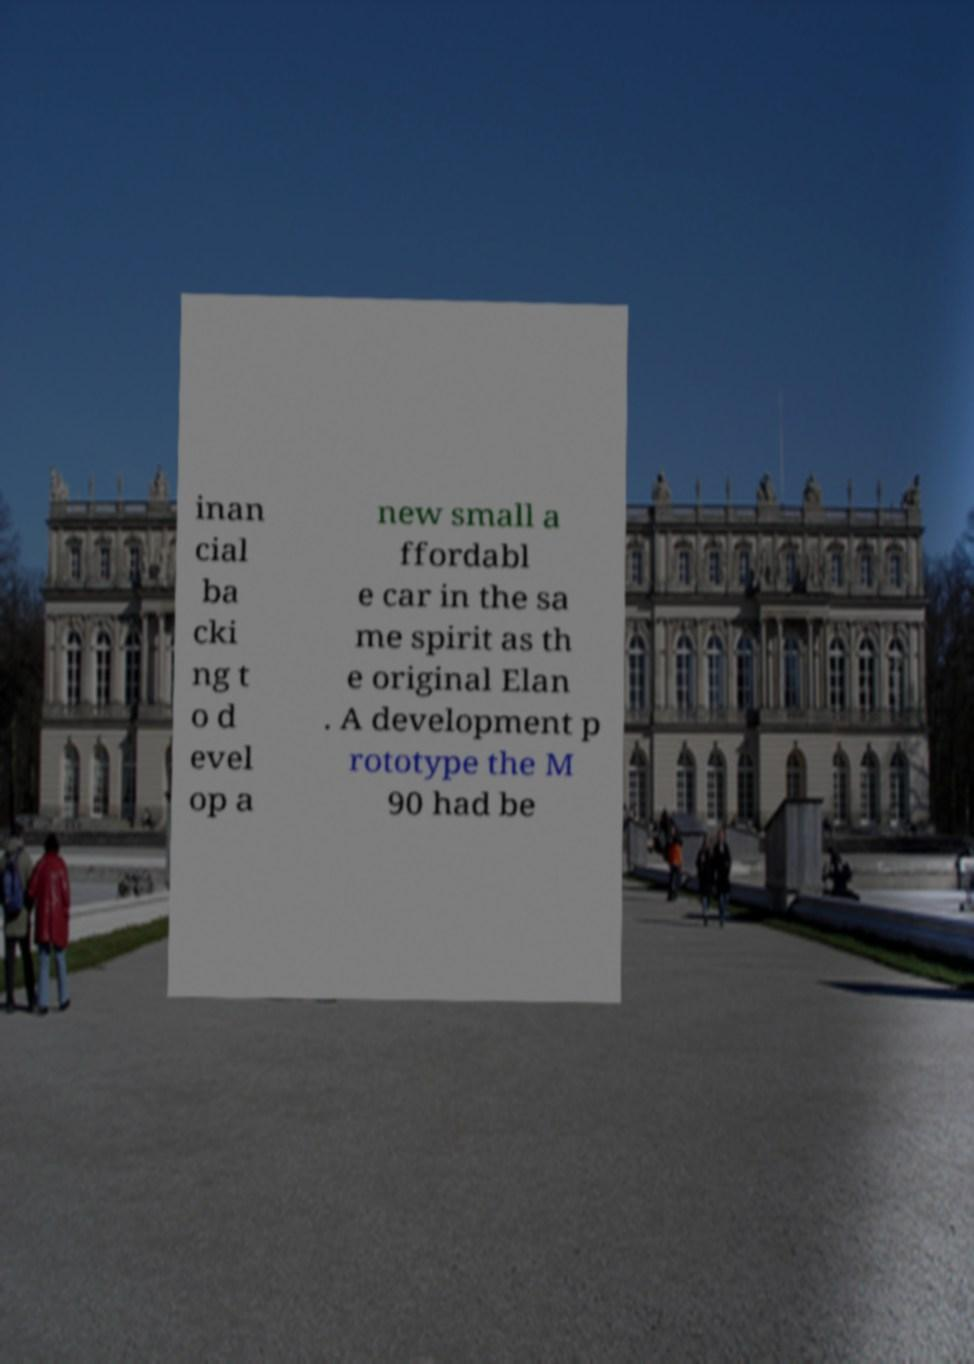I need the written content from this picture converted into text. Can you do that? inan cial ba cki ng t o d evel op a new small a ffordabl e car in the sa me spirit as th e original Elan . A development p rototype the M 90 had be 